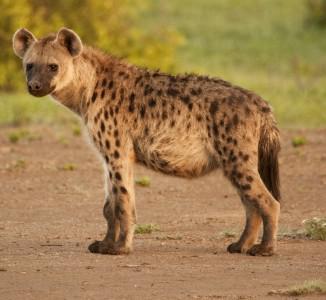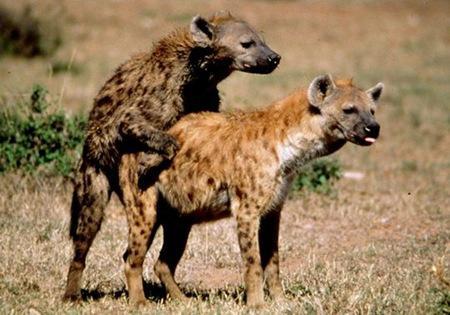The first image is the image on the left, the second image is the image on the right. Examine the images to the left and right. Is the description "A hyena has its mouth wide open" accurate? Answer yes or no. No. 